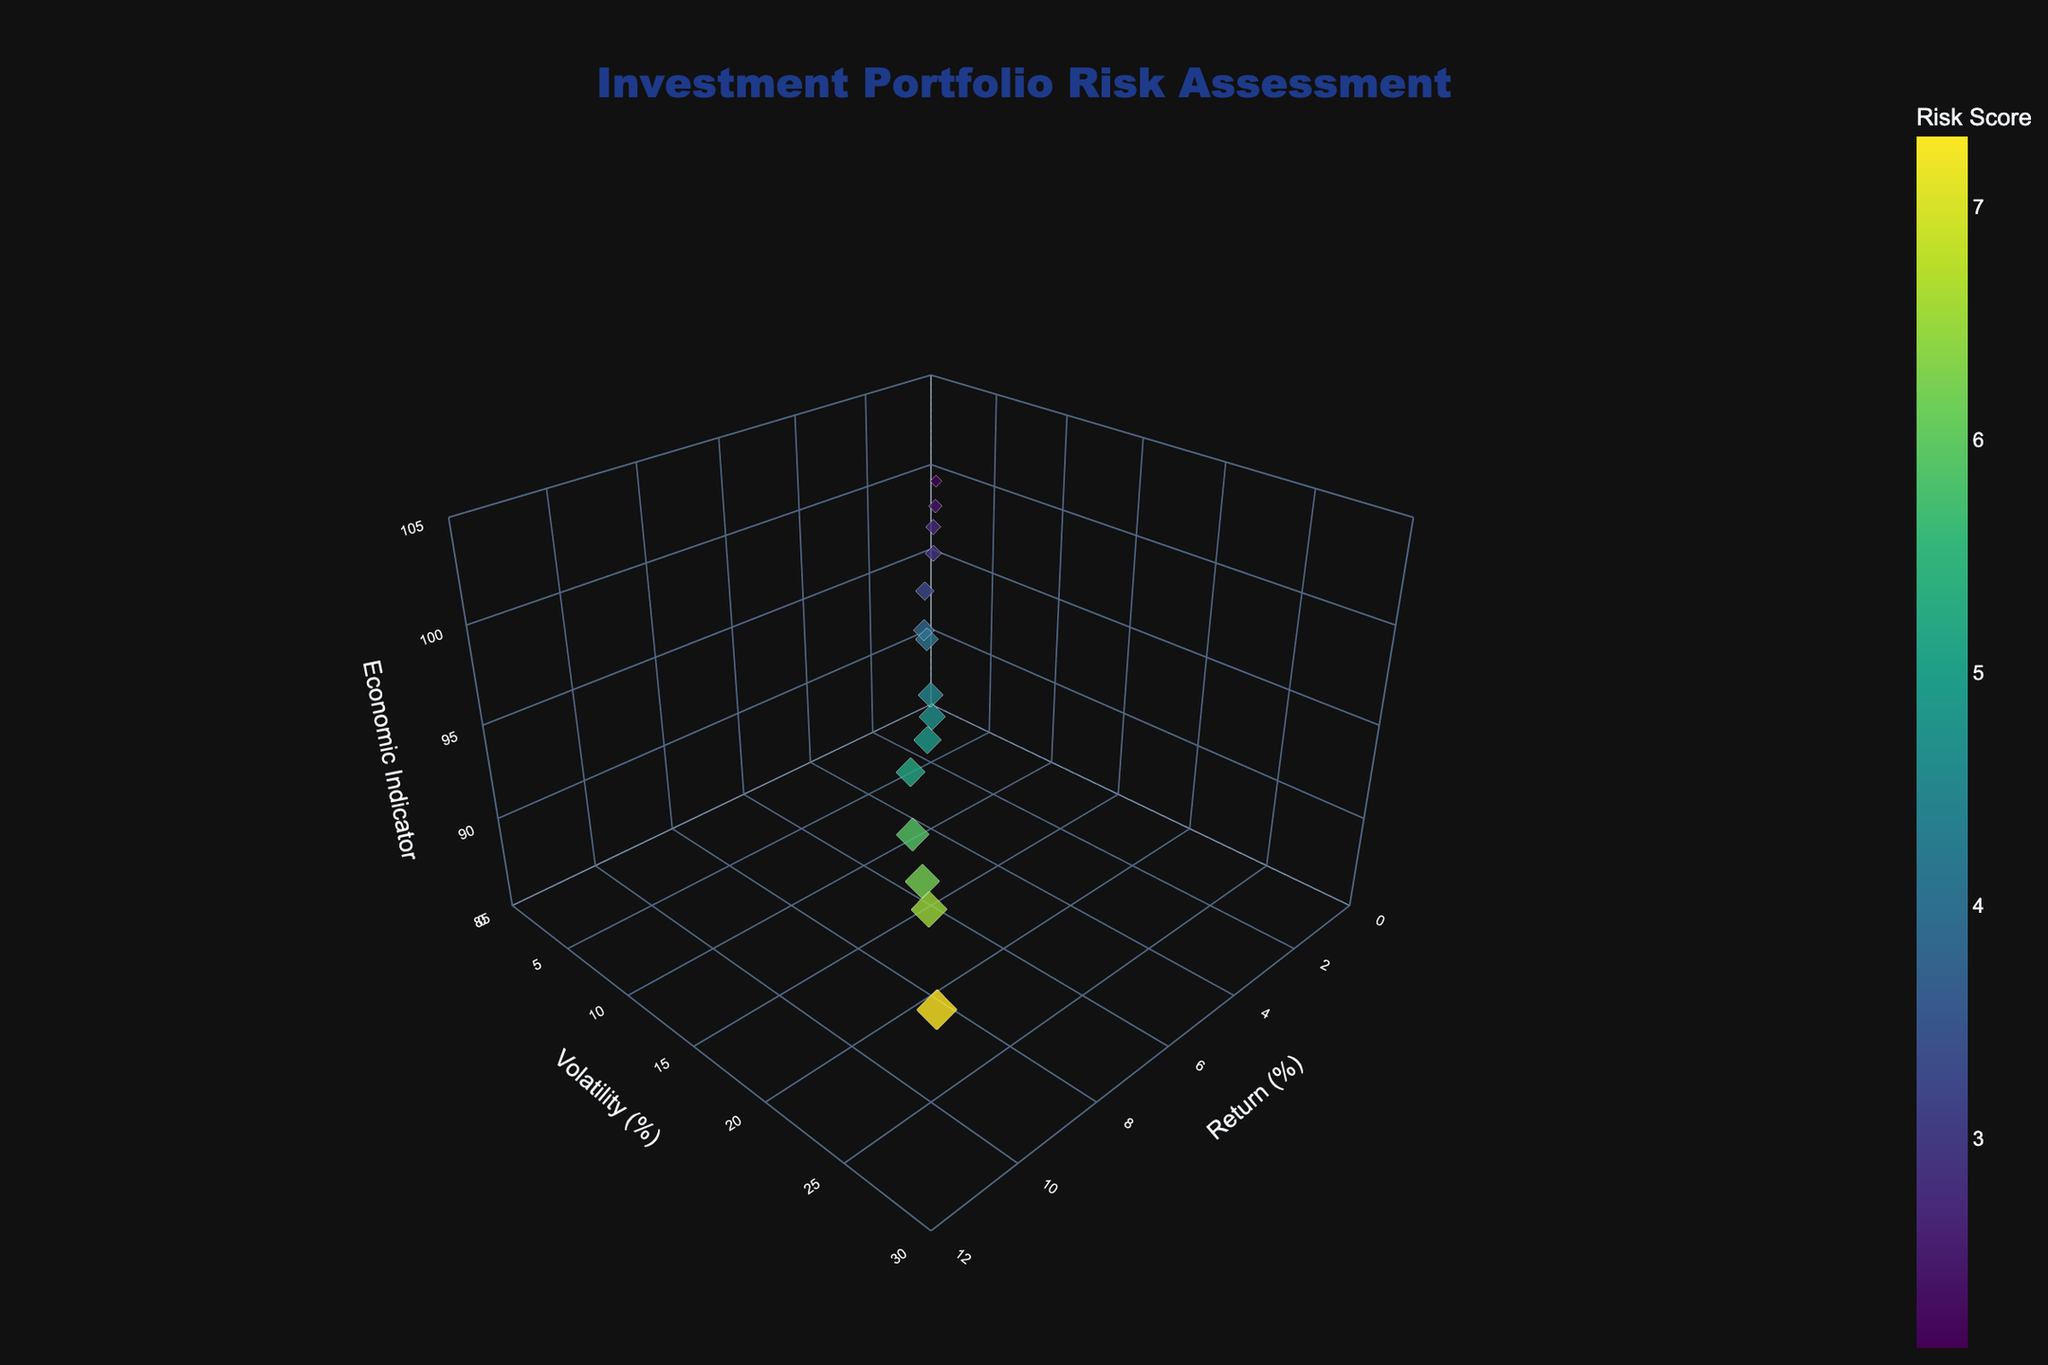What is the title of the plot? The title of the plot can be found at the top of the figure. It reads 'Investment Portfolio Risk Assessment'.
Answer: Investment Portfolio Risk Assessment What does the size and color of the markers represent? In the plot, the size of the markers is determined by the 'Risk Score' multiplied by 3, and the color represents the 'Risk Score' as well, which can be inferred from the colorbar next to the plot labeled 'Risk Score'.
Answer: Risk Score How many data points are shown in the plot? By counting the markers in the plot, we can see there are a total of 15 data points represented by the markers.
Answer: 15 What are the axis labels for the 3D plot? The axis labels can be found next to each axis in the plot. They are: 'Return (%)' for the x-axis, 'Volatility (%)' for the y-axis, and 'Economic Indicator' for the z-axis.
Answer: Return (%), Volatility (%), Economic Indicator Which data point has the highest risk score? By observing the markers and the size, as well as color scale, the data point with the highest 'Risk Score' is located at (Return: 10.2, Volatility: 25.8, Economic Indicator: 90.6) with a risk score of 7.3.
Answer: (Return: 10.2, Volatility: 25.8, Economic Indicator: 90.6) Which data point has the lowest 'Economic Indicator', and what is its 'Risk Score'? By locating the lowest point on the economic indicator (z-axis), we find the data point at (Return: 10.2, Volatility: 25.8, Economic Indicator: 90.6). The 'Risk Score' of this point is 7.3.
Answer: 7.3 What is the relationship between 'Return' and 'Volatility'? To determine the relationship, observe the distribution of data points along the 'Return' and 'Volatility' axes. Typically, higher volatility corresponds to higher returns, as most points with higher returns also have higher volatility.
Answer: Higher returns generally correlate with higher volatility Calculate the average 'Risk Score' of all data points. Sum all the 'Risk Scores' (3.8+5.2+2.7+6.5+4.5+3.3+5.9+2.1+7.3+4.1+4.9+2.9+6.2+2.4+4.7) to get 66.5. Divide the total by the number of data points (15). The average is 66.5 / 15 = 4.43.
Answer: 4.43 Which data point has the highest 'Return', and what is its 'Volatility'? By locating the highest point on the return (x-axis), we find the data point at (Return: 10.2, Volatility: 25.8, Economic Indicator: 90.6). The 'Volatility' of this point is 25.8%.
Answer: 25.8 